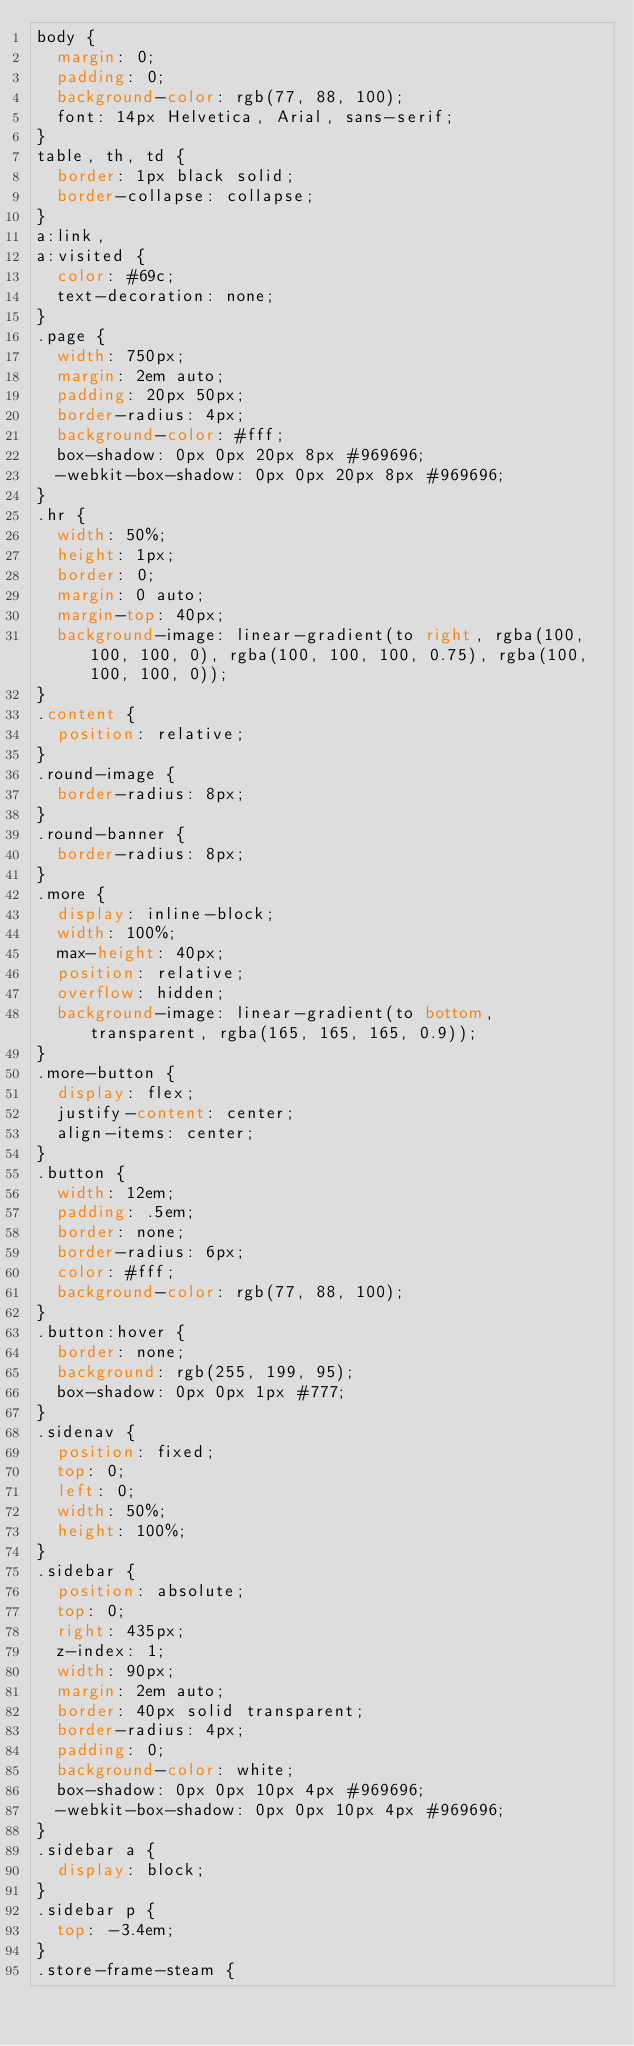Convert code to text. <code><loc_0><loc_0><loc_500><loc_500><_CSS_>body {
  margin: 0;
  padding: 0;
  background-color: rgb(77, 88, 100);
  font: 14px Helvetica, Arial, sans-serif;
}
table, th, td {
  border: 1px black solid;
  border-collapse: collapse;
}
a:link,
a:visited {
  color: #69c;
  text-decoration: none;
}
.page {
  width: 750px;
  margin: 2em auto;
  padding: 20px 50px;
  border-radius: 4px;
  background-color: #fff;
  box-shadow: 0px 0px 20px 8px #969696;
  -webkit-box-shadow: 0px 0px 20px 8px #969696;
}
.hr {
  width: 50%;
  height: 1px;
  border: 0;
  margin: 0 auto;
  margin-top: 40px;
  background-image: linear-gradient(to right, rgba(100, 100, 100, 0), rgba(100, 100, 100, 0.75), rgba(100, 100, 100, 0));
}
.content {
  position: relative;
}
.round-image {
  border-radius: 8px;
}
.round-banner {
  border-radius: 8px;
}
.more {
  display: inline-block;
  width: 100%;
  max-height: 40px;
  position: relative;
  overflow: hidden;
  background-image: linear-gradient(to bottom, transparent, rgba(165, 165, 165, 0.9));
}
.more-button {
  display: flex;
  justify-content: center;
  align-items: center;
}
.button {
  width: 12em;
  padding: .5em;
  border: none;
  border-radius: 6px;
  color: #fff;
  background-color: rgb(77, 88, 100);
}
.button:hover {
  border: none;
  background: rgb(255, 199, 95);
  box-shadow: 0px 0px 1px #777;
}
.sidenav {
  position: fixed;
  top: 0;
  left: 0;
  width: 50%;
  height: 100%;
}
.sidebar {
  position: absolute;
  top: 0;
  right: 435px;
  z-index: 1;
  width: 90px;
  margin: 2em auto;
  border: 40px solid transparent;
  border-radius: 4px;
  padding: 0;
  background-color: white;
  box-shadow: 0px 0px 10px 4px #969696;
  -webkit-box-shadow: 0px 0px 10px 4px #969696;
}
.sidebar a {
  display: block;
}
.sidebar p {
  top: -3.4em;
}
.store-frame-steam {</code> 